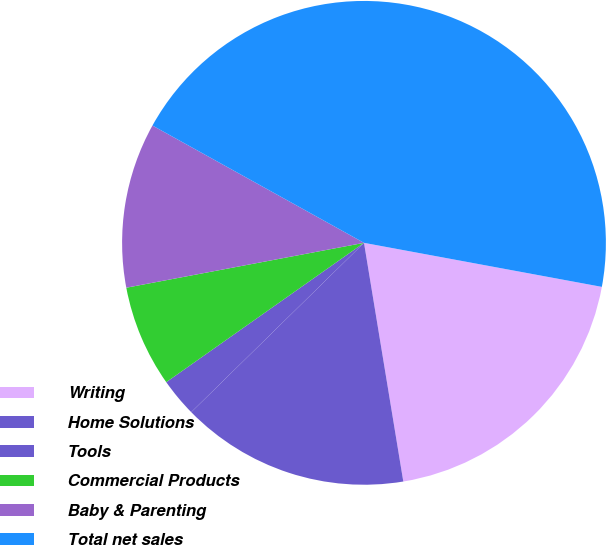<chart> <loc_0><loc_0><loc_500><loc_500><pie_chart><fcel>Writing<fcel>Home Solutions<fcel>Tools<fcel>Commercial Products<fcel>Baby & Parenting<fcel>Total net sales<nl><fcel>19.49%<fcel>15.26%<fcel>2.57%<fcel>6.8%<fcel>11.03%<fcel>44.86%<nl></chart> 